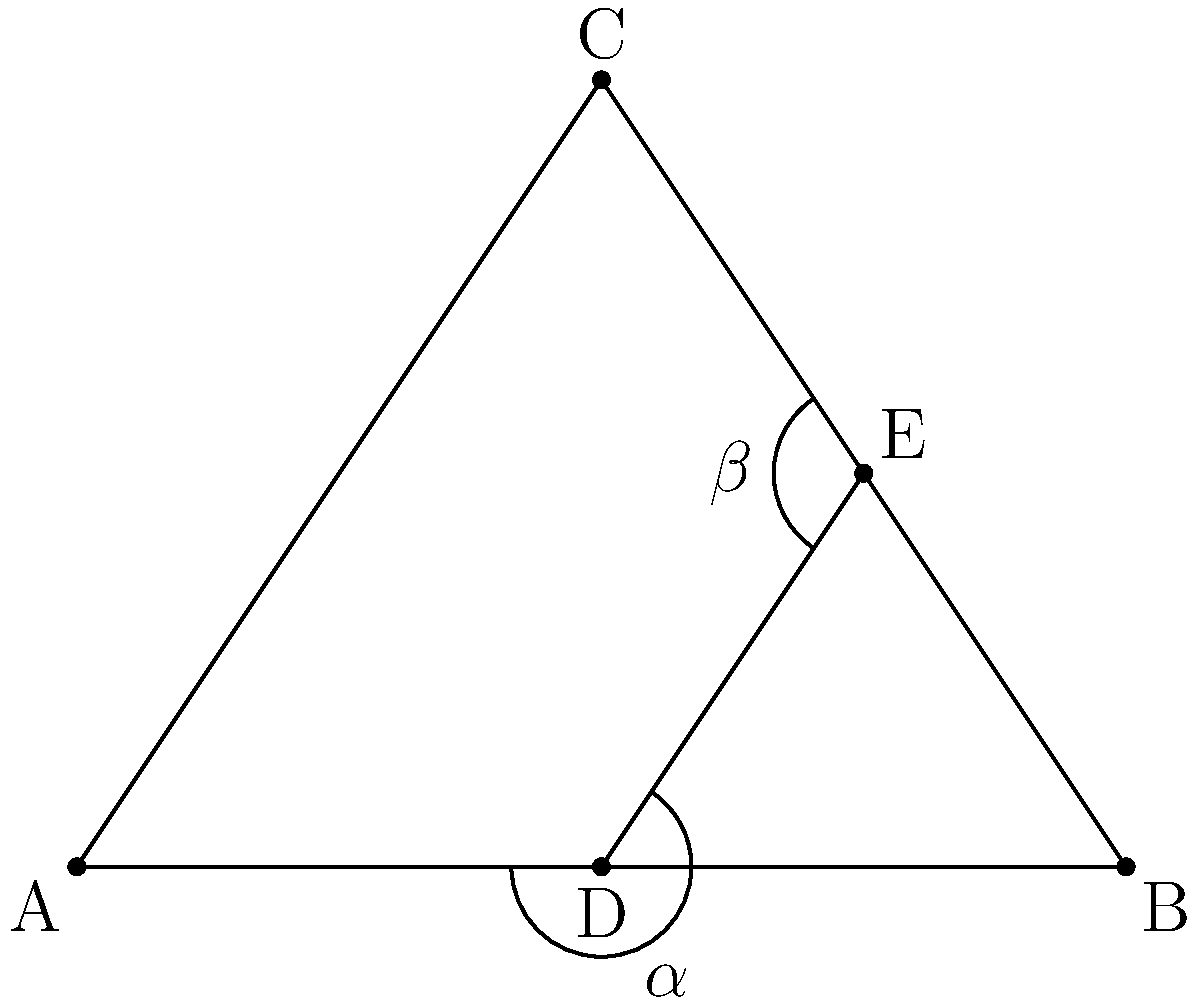In the Stuttgart TV Tower's structural design, consider the simplified triangular cross-section ABC with a bisecting line DE. If angle $\alpha = 35°$, what is the measure of angle $\beta$? To solve this problem, we'll use the properties of congruent angles and the characteristics of bisectors in triangles:

1. Line DE bisects angle ADB, creating two congruent angles: $\angle ADE$ and $\angle BDE$.

2. In a triangle, an angle bisector creates two congruent angles where it intersects the opposite side. Therefore, $\angle AED \cong \angle CED$.

3. We are given that $\alpha = 35°$. This is the measure of $\angle ADE$.

4. Since DE bisects $\angle ADB$, we know that $\angle BDE = 35°$ as well.

5. In a triangle, the sum of all angles is 180°. Therefore:
   $\angle ADE + \angle BDE + \angle AEB = 180°$
   $35° + 35° + \angle AEB = 180°$
   $\angle AEB = 180° - 70° = 110°$

6. As established in step 2, $\angle AED \cong \angle CED$. This means that DE also bisects $\angle AEB$.

7. Since $\angle AEB = 110°$, each of the angles formed by its bisector must be 55°.

8. Therefore, $\beta = \angle CED = 55°$.
Answer: $55°$ 